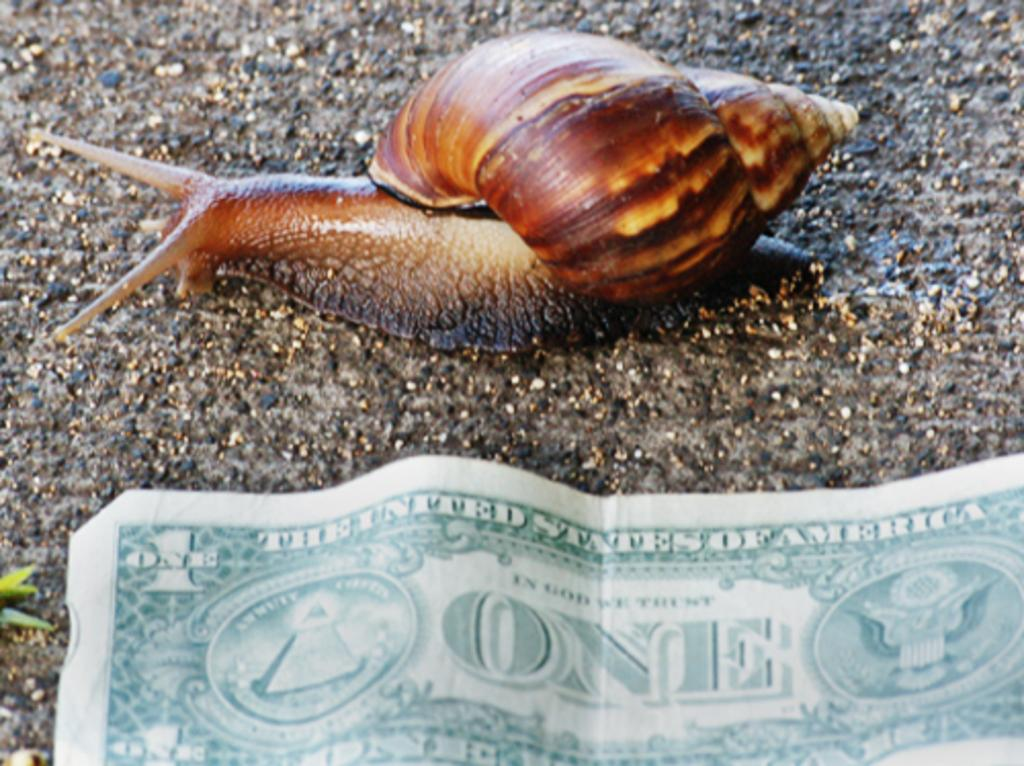What type of animal can be seen on the ground in the image? There is a snail on the ground in the image. What else is present in the image besides the snail? There is a currency in the image. What type of bag is being carried by the snail in the image? There is no bag present in the image, as the snail is not carrying anything. 